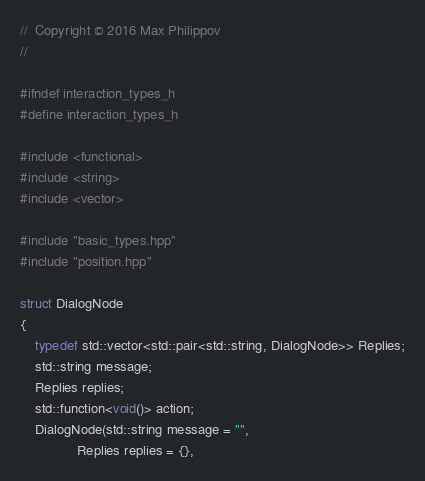Convert code to text. <code><loc_0><loc_0><loc_500><loc_500><_C++_>//  Copyright © 2016 Max Philippov
//

#ifndef interaction_types_h
#define interaction_types_h

#include <functional>
#include <string>
#include <vector>

#include "basic_types.hpp"
#include "position.hpp"

struct DialogNode
{
    typedef std::vector<std::pair<std::string, DialogNode>> Replies;
    std::string message;
    Replies replies;
    std::function<void()> action;
    DialogNode(std::string message = "",
               Replies replies = {},</code> 